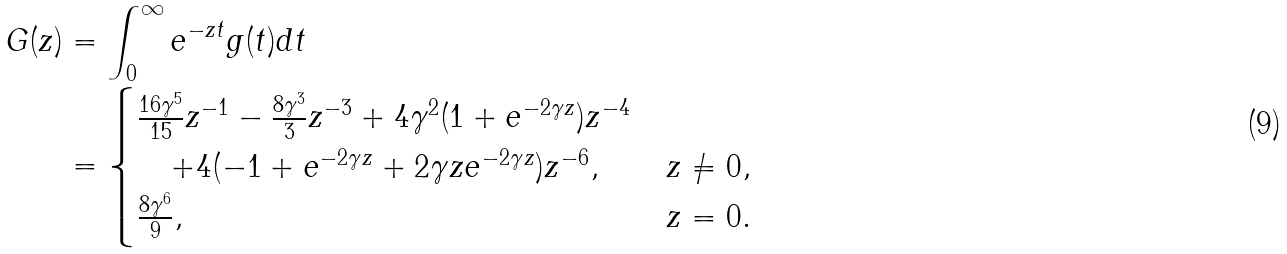<formula> <loc_0><loc_0><loc_500><loc_500>G ( z ) & = \int _ { 0 } ^ { \infty } e ^ { - z t } g ( t ) d t \\ & = \begin{cases} \frac { 1 6 \gamma ^ { 5 } } { 1 5 } z ^ { - 1 } - \frac { 8 \gamma ^ { 3 } } { 3 } z ^ { - 3 } + 4 \gamma ^ { 2 } ( 1 + e ^ { - 2 \gamma z } ) z ^ { - 4 } \\ \quad + 4 ( - 1 + e ^ { - 2 \gamma z } + 2 \gamma z e ^ { - 2 \gamma z } ) z ^ { - 6 } , \quad & z \ne 0 , \\ \frac { 8 \gamma ^ { 6 } } { 9 } , & z = 0 . \end{cases}</formula> 